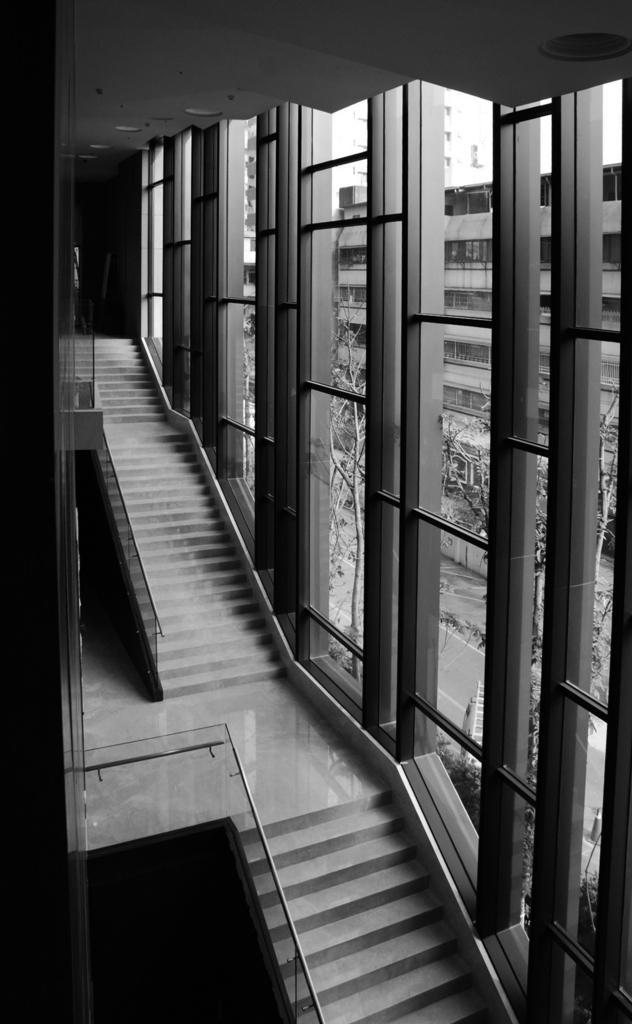How would you summarize this image in a sentence or two? In this image in front there are stairs. On the right side of the image there are glass windows through which we can see trees, buildings. 